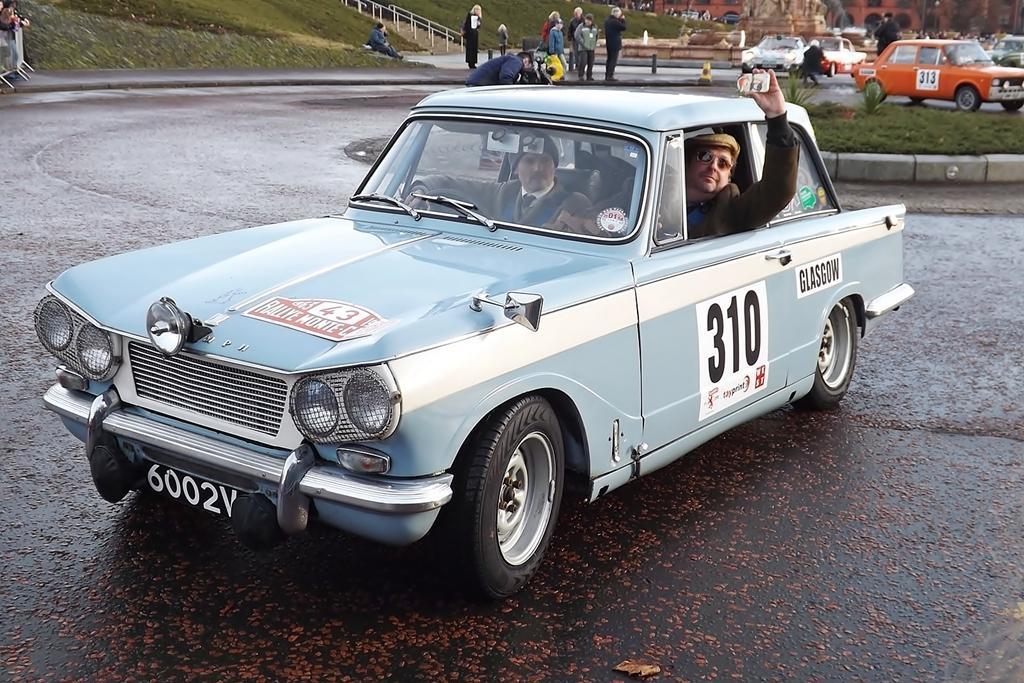Can you describe this image briefly? In the foreground of this image, there is a car on the road and there are men sitting in side the car and a man kept hand outside in the air. In the background, there is the grass, plants, vehicles moving on the road, few bollard, persons standing, fountain, sculpture and the building. On the top left, there is a slope grass land and a man sitting on it and we can also see the stairs. 